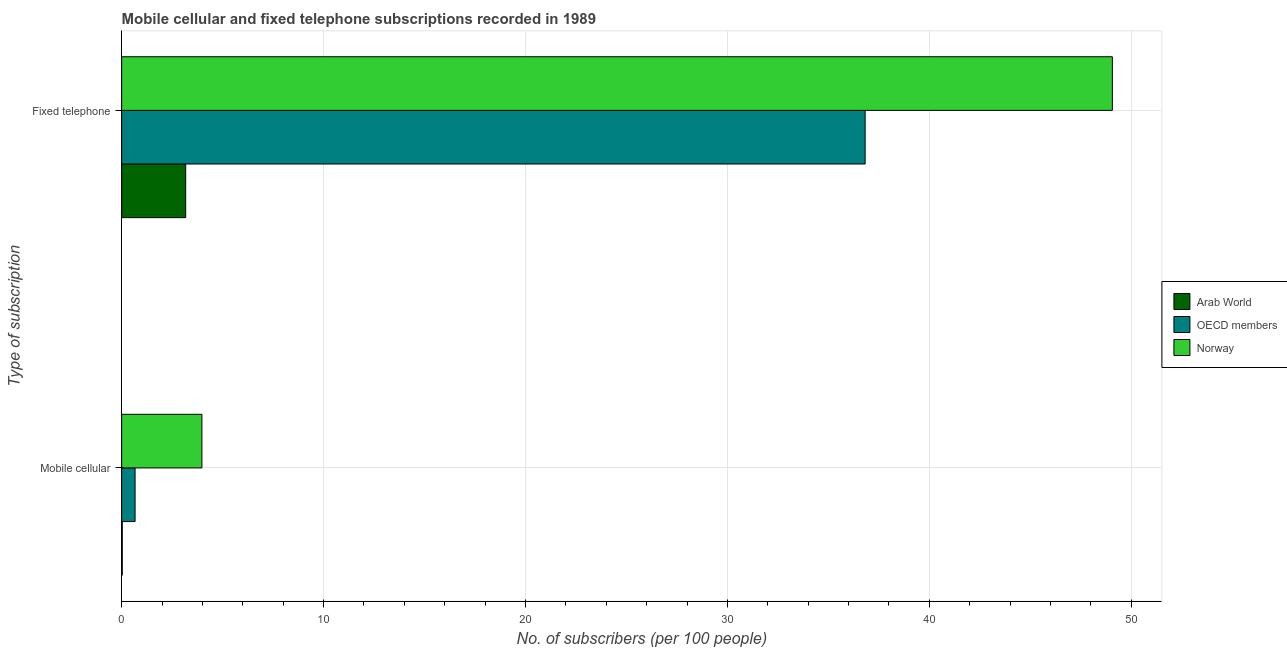Are the number of bars per tick equal to the number of legend labels?
Your response must be concise. Yes. What is the label of the 2nd group of bars from the top?
Offer a very short reply. Mobile cellular. What is the number of mobile cellular subscribers in OECD members?
Offer a very short reply. 0.66. Across all countries, what is the maximum number of mobile cellular subscribers?
Provide a succinct answer. 3.97. Across all countries, what is the minimum number of mobile cellular subscribers?
Your response must be concise. 0.03. In which country was the number of mobile cellular subscribers minimum?
Give a very brief answer. Arab World. What is the total number of fixed telephone subscribers in the graph?
Offer a terse response. 89.05. What is the difference between the number of mobile cellular subscribers in Norway and that in Arab World?
Give a very brief answer. 3.94. What is the difference between the number of mobile cellular subscribers in OECD members and the number of fixed telephone subscribers in Arab World?
Offer a very short reply. -2.51. What is the average number of fixed telephone subscribers per country?
Offer a terse response. 29.68. What is the difference between the number of fixed telephone subscribers and number of mobile cellular subscribers in Arab World?
Your response must be concise. 3.14. In how many countries, is the number of fixed telephone subscribers greater than 32 ?
Your response must be concise. 2. What is the ratio of the number of mobile cellular subscribers in Arab World to that in Norway?
Offer a very short reply. 0.01. What does the 3rd bar from the top in Mobile cellular represents?
Provide a short and direct response. Arab World. How many countries are there in the graph?
Make the answer very short. 3. Does the graph contain grids?
Provide a succinct answer. Yes. What is the title of the graph?
Your answer should be compact. Mobile cellular and fixed telephone subscriptions recorded in 1989. What is the label or title of the X-axis?
Give a very brief answer. No. of subscribers (per 100 people). What is the label or title of the Y-axis?
Ensure brevity in your answer.  Type of subscription. What is the No. of subscribers (per 100 people) in Arab World in Mobile cellular?
Your response must be concise. 0.03. What is the No. of subscribers (per 100 people) in OECD members in Mobile cellular?
Provide a succinct answer. 0.66. What is the No. of subscribers (per 100 people) of Norway in Mobile cellular?
Offer a terse response. 3.97. What is the No. of subscribers (per 100 people) in Arab World in Fixed telephone?
Provide a succinct answer. 3.17. What is the No. of subscribers (per 100 people) in OECD members in Fixed telephone?
Provide a short and direct response. 36.82. What is the No. of subscribers (per 100 people) of Norway in Fixed telephone?
Make the answer very short. 49.06. Across all Type of subscription, what is the maximum No. of subscribers (per 100 people) in Arab World?
Offer a terse response. 3.17. Across all Type of subscription, what is the maximum No. of subscribers (per 100 people) of OECD members?
Make the answer very short. 36.82. Across all Type of subscription, what is the maximum No. of subscribers (per 100 people) of Norway?
Provide a succinct answer. 49.06. Across all Type of subscription, what is the minimum No. of subscribers (per 100 people) of Arab World?
Offer a very short reply. 0.03. Across all Type of subscription, what is the minimum No. of subscribers (per 100 people) in OECD members?
Offer a very short reply. 0.66. Across all Type of subscription, what is the minimum No. of subscribers (per 100 people) of Norway?
Your response must be concise. 3.97. What is the total No. of subscribers (per 100 people) of Arab World in the graph?
Give a very brief answer. 3.2. What is the total No. of subscribers (per 100 people) of OECD members in the graph?
Ensure brevity in your answer.  37.48. What is the total No. of subscribers (per 100 people) of Norway in the graph?
Make the answer very short. 53.04. What is the difference between the No. of subscribers (per 100 people) in Arab World in Mobile cellular and that in Fixed telephone?
Your answer should be compact. -3.14. What is the difference between the No. of subscribers (per 100 people) in OECD members in Mobile cellular and that in Fixed telephone?
Your answer should be very brief. -36.16. What is the difference between the No. of subscribers (per 100 people) of Norway in Mobile cellular and that in Fixed telephone?
Make the answer very short. -45.09. What is the difference between the No. of subscribers (per 100 people) of Arab World in Mobile cellular and the No. of subscribers (per 100 people) of OECD members in Fixed telephone?
Ensure brevity in your answer.  -36.79. What is the difference between the No. of subscribers (per 100 people) in Arab World in Mobile cellular and the No. of subscribers (per 100 people) in Norway in Fixed telephone?
Your answer should be compact. -49.03. What is the difference between the No. of subscribers (per 100 people) in OECD members in Mobile cellular and the No. of subscribers (per 100 people) in Norway in Fixed telephone?
Make the answer very short. -48.4. What is the average No. of subscribers (per 100 people) of Arab World per Type of subscription?
Offer a very short reply. 1.6. What is the average No. of subscribers (per 100 people) of OECD members per Type of subscription?
Your answer should be very brief. 18.74. What is the average No. of subscribers (per 100 people) of Norway per Type of subscription?
Make the answer very short. 26.52. What is the difference between the No. of subscribers (per 100 people) in Arab World and No. of subscribers (per 100 people) in OECD members in Mobile cellular?
Keep it short and to the point. -0.63. What is the difference between the No. of subscribers (per 100 people) in Arab World and No. of subscribers (per 100 people) in Norway in Mobile cellular?
Provide a succinct answer. -3.94. What is the difference between the No. of subscribers (per 100 people) of OECD members and No. of subscribers (per 100 people) of Norway in Mobile cellular?
Ensure brevity in your answer.  -3.31. What is the difference between the No. of subscribers (per 100 people) in Arab World and No. of subscribers (per 100 people) in OECD members in Fixed telephone?
Provide a short and direct response. -33.65. What is the difference between the No. of subscribers (per 100 people) of Arab World and No. of subscribers (per 100 people) of Norway in Fixed telephone?
Offer a very short reply. -45.89. What is the difference between the No. of subscribers (per 100 people) in OECD members and No. of subscribers (per 100 people) in Norway in Fixed telephone?
Give a very brief answer. -12.24. What is the ratio of the No. of subscribers (per 100 people) of Arab World in Mobile cellular to that in Fixed telephone?
Make the answer very short. 0.01. What is the ratio of the No. of subscribers (per 100 people) in OECD members in Mobile cellular to that in Fixed telephone?
Give a very brief answer. 0.02. What is the ratio of the No. of subscribers (per 100 people) in Norway in Mobile cellular to that in Fixed telephone?
Offer a terse response. 0.08. What is the difference between the highest and the second highest No. of subscribers (per 100 people) of Arab World?
Provide a short and direct response. 3.14. What is the difference between the highest and the second highest No. of subscribers (per 100 people) of OECD members?
Provide a succinct answer. 36.16. What is the difference between the highest and the second highest No. of subscribers (per 100 people) of Norway?
Your answer should be very brief. 45.09. What is the difference between the highest and the lowest No. of subscribers (per 100 people) in Arab World?
Make the answer very short. 3.14. What is the difference between the highest and the lowest No. of subscribers (per 100 people) of OECD members?
Your answer should be very brief. 36.16. What is the difference between the highest and the lowest No. of subscribers (per 100 people) of Norway?
Make the answer very short. 45.09. 